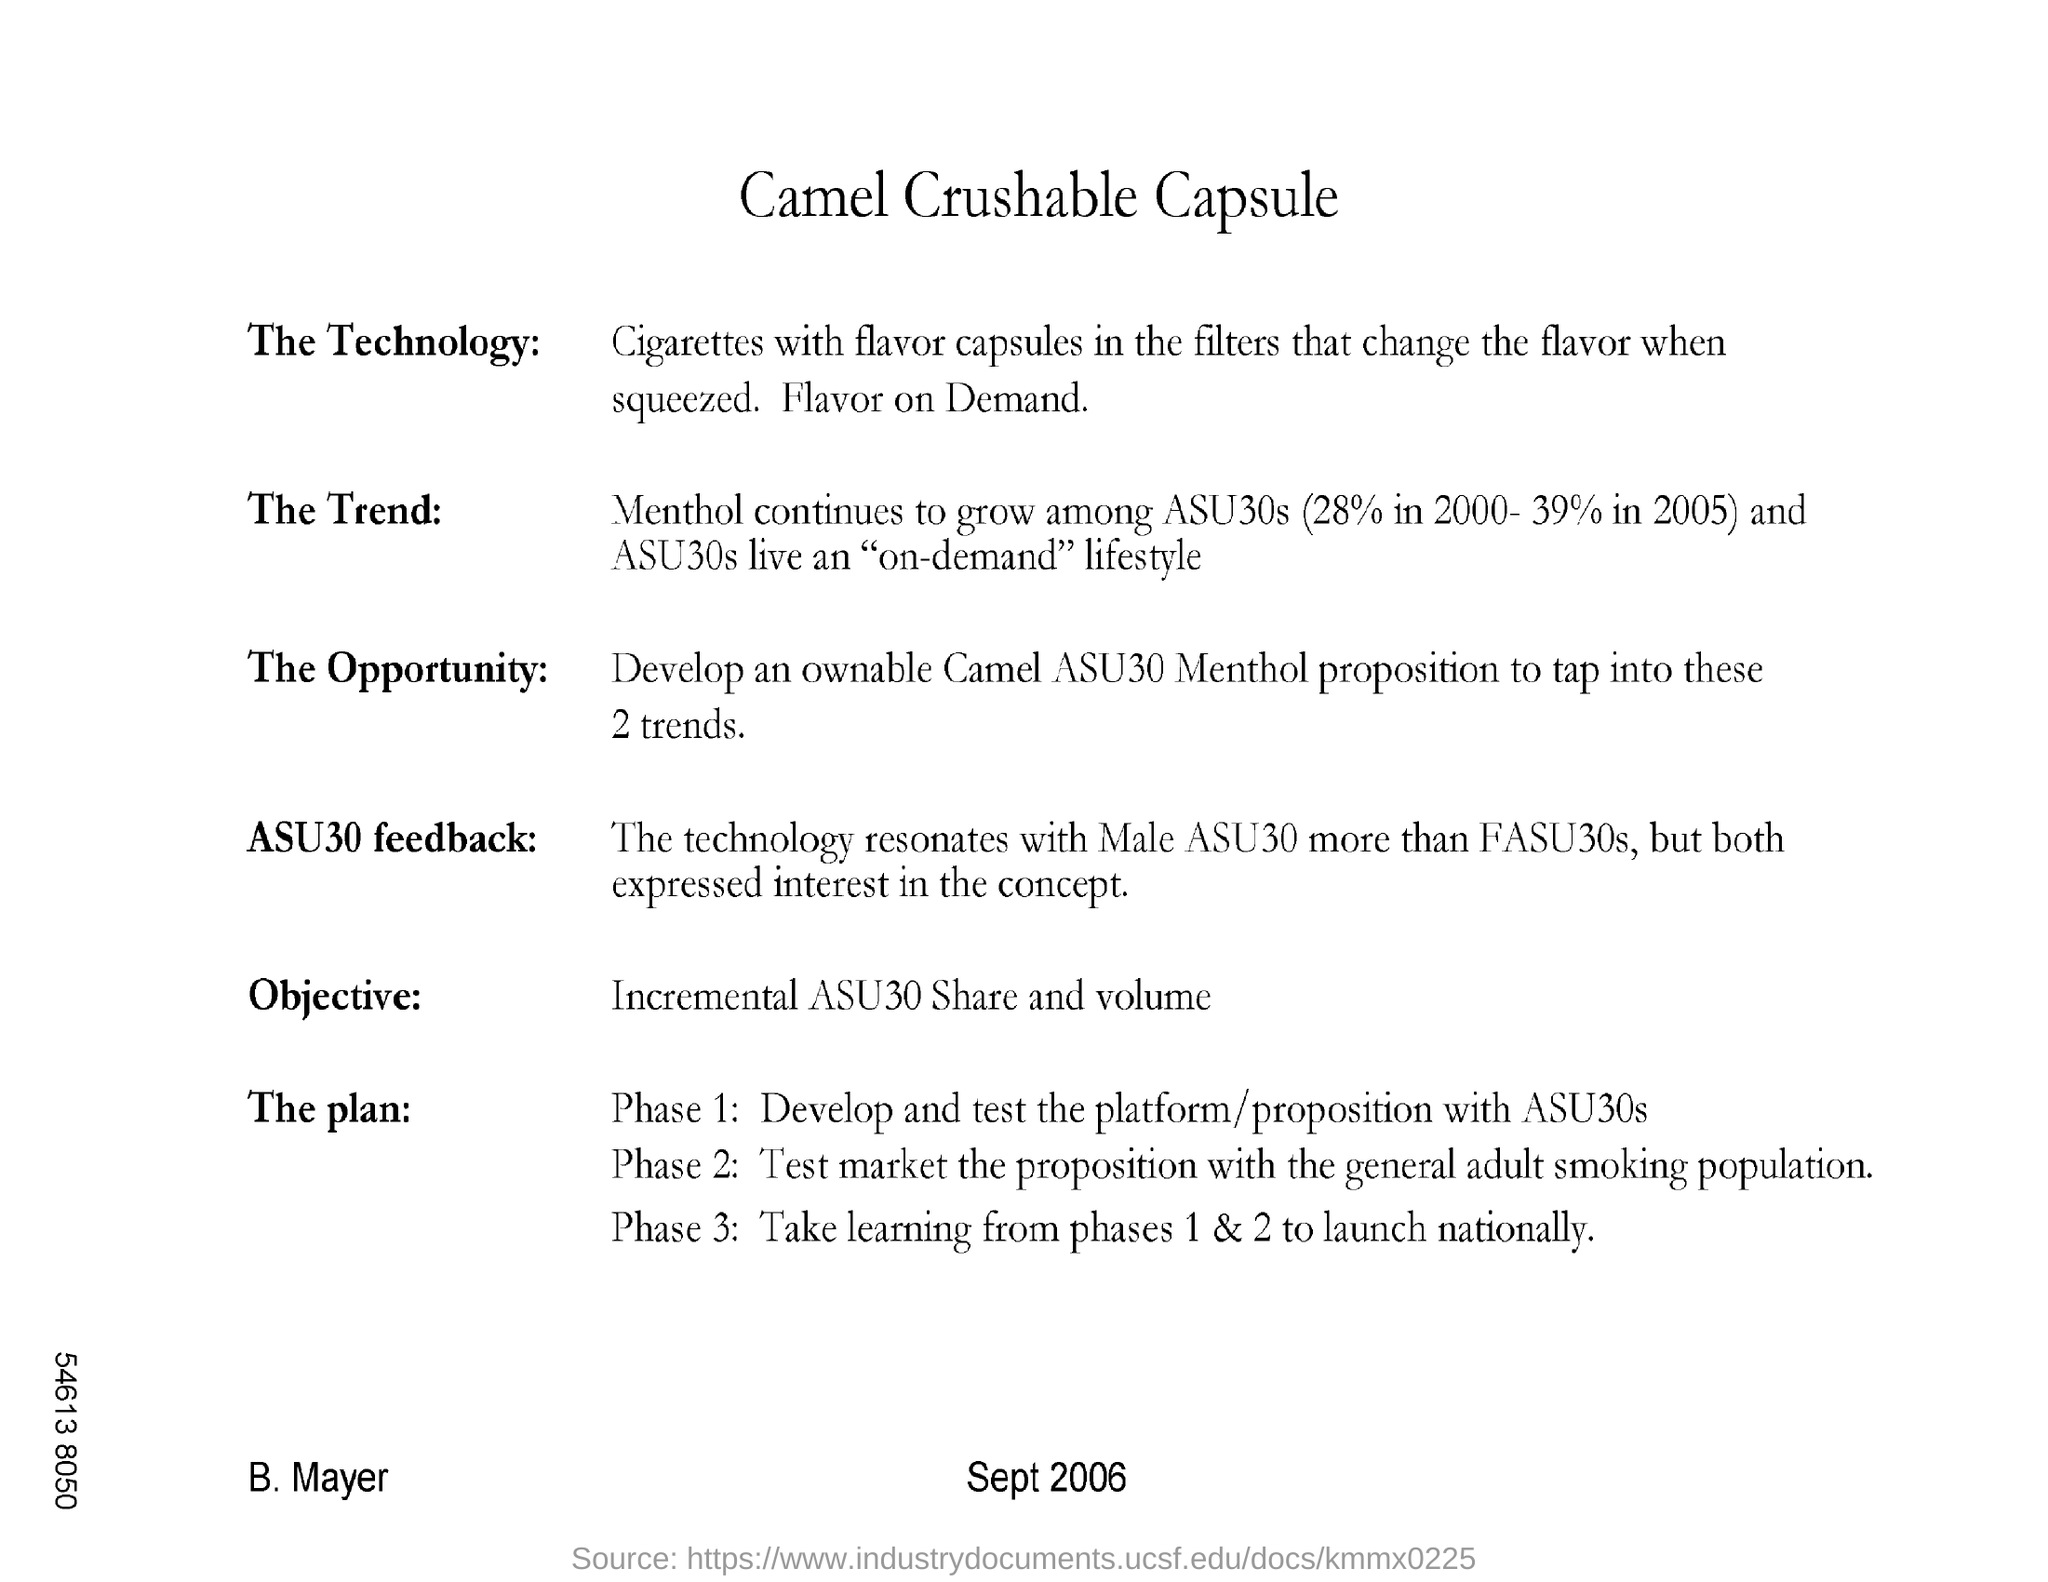Point out several critical features in this image. Individuals in their 30s who live an on-demand lifestyle have come to expect immediate access to goods and services, and they are willing to pay a premium for convenience. In 2000, the menthol content was reported to be 28%. The flavor capsules inside the filters are responsible for changing the flavor when squeezed. Marketing the product is involved in Phase 2. Phase 3 is primarily focused on national implementation of the learnings gained from Phases 1 and 2, with the goal of taking learning from the local contexts to a national level. 